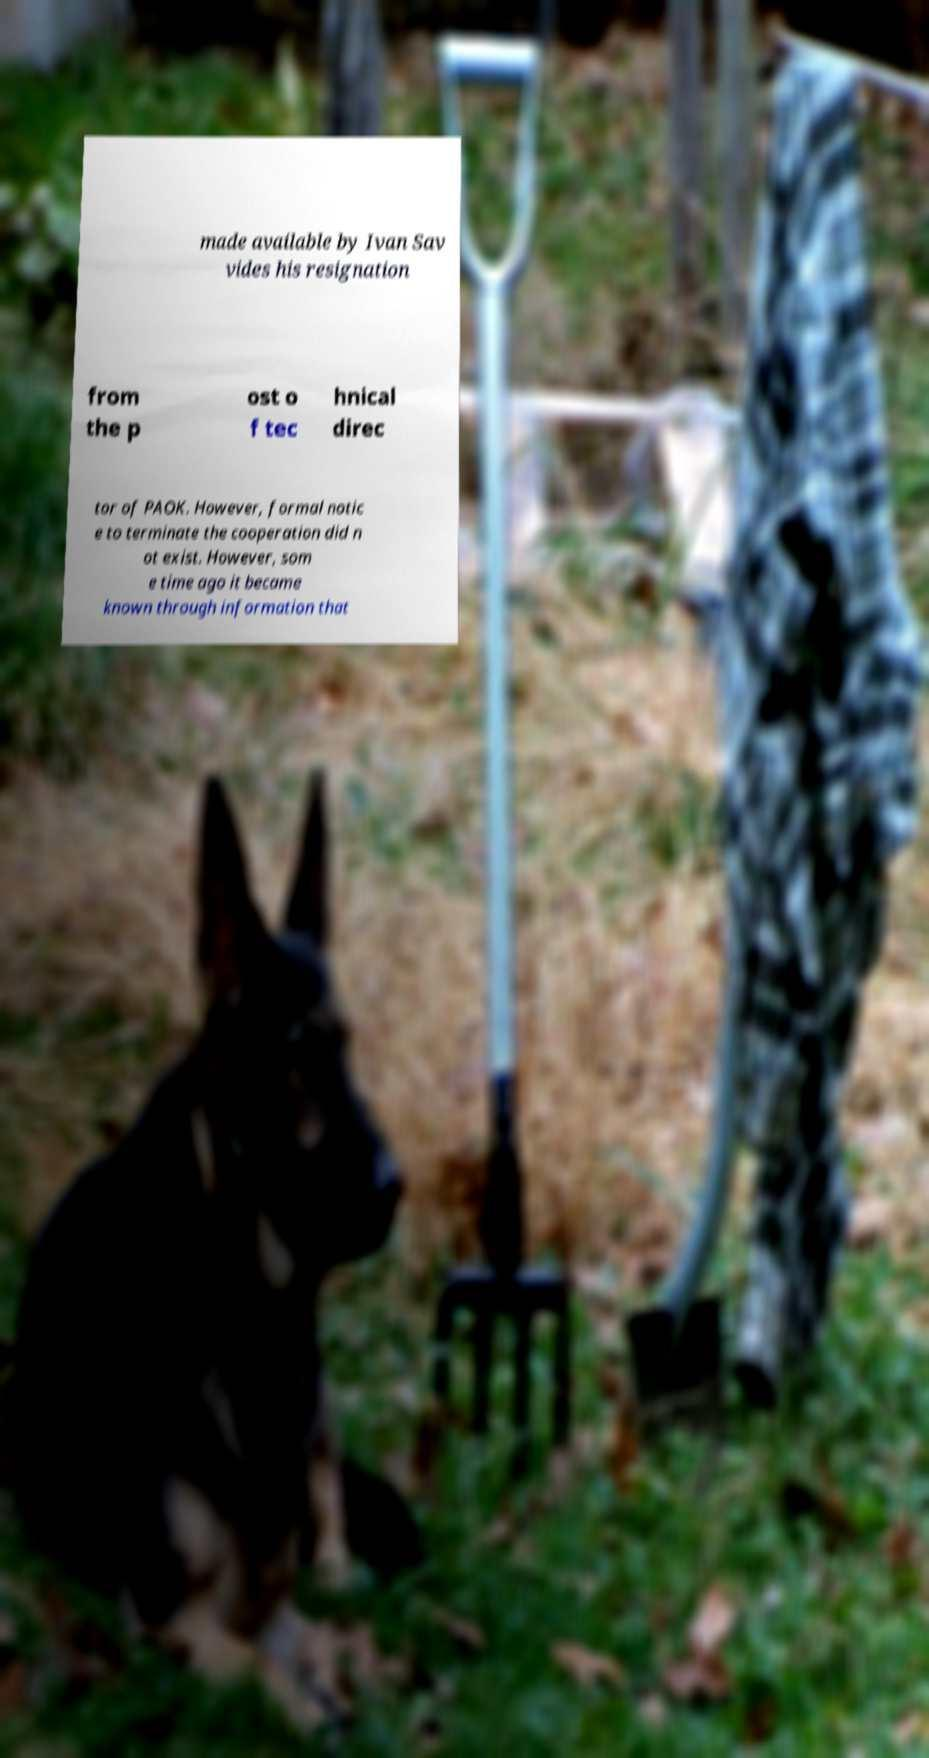Please identify and transcribe the text found in this image. The text in the image reads: 'made available by Ivan Savvides his resignation from the post of technical director of PAOK. However, formal notice to terminate the cooperation did not exist. However, some time ago it became known through information that'. The text captures a formal statement presumably related to Ivan Savvides and his role at PAOK, but it might be incomplete as the image does not show the full text. 